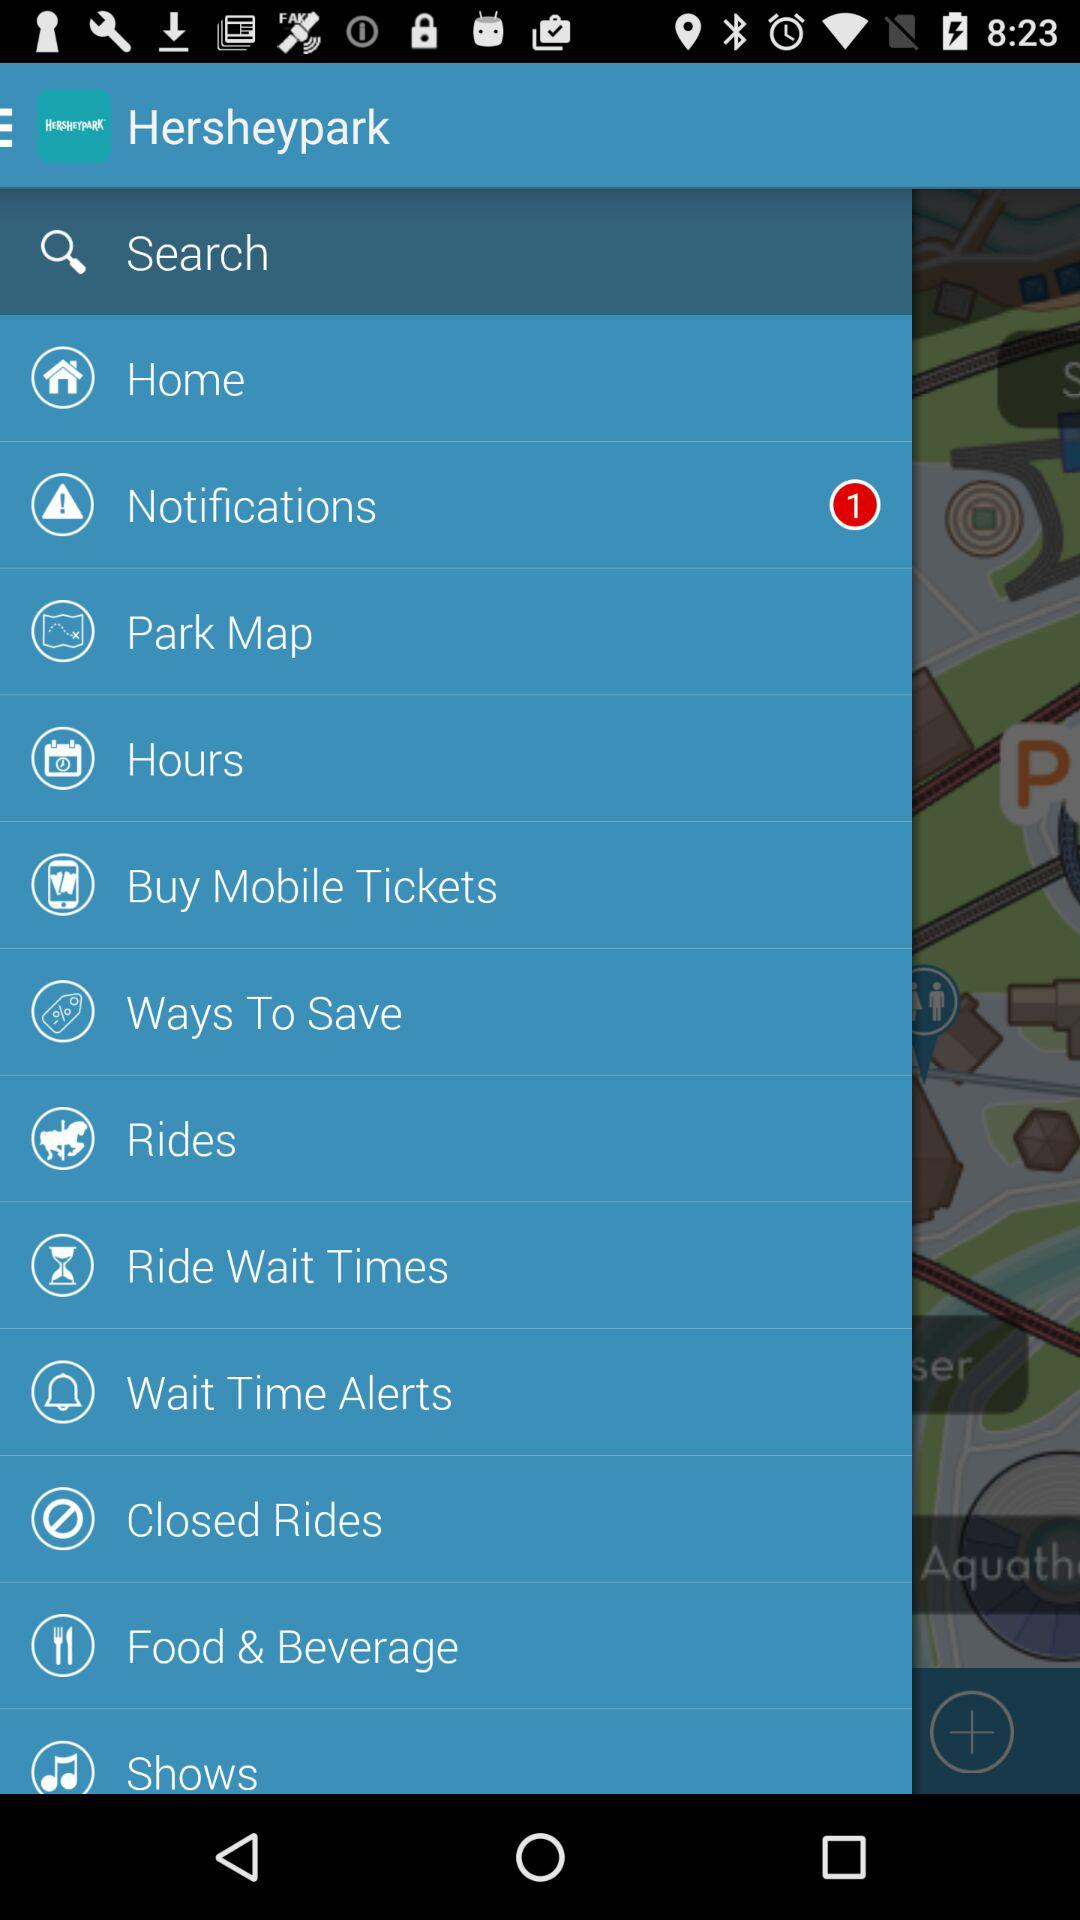How many unread notifications are there? There is 1 unread notification. 